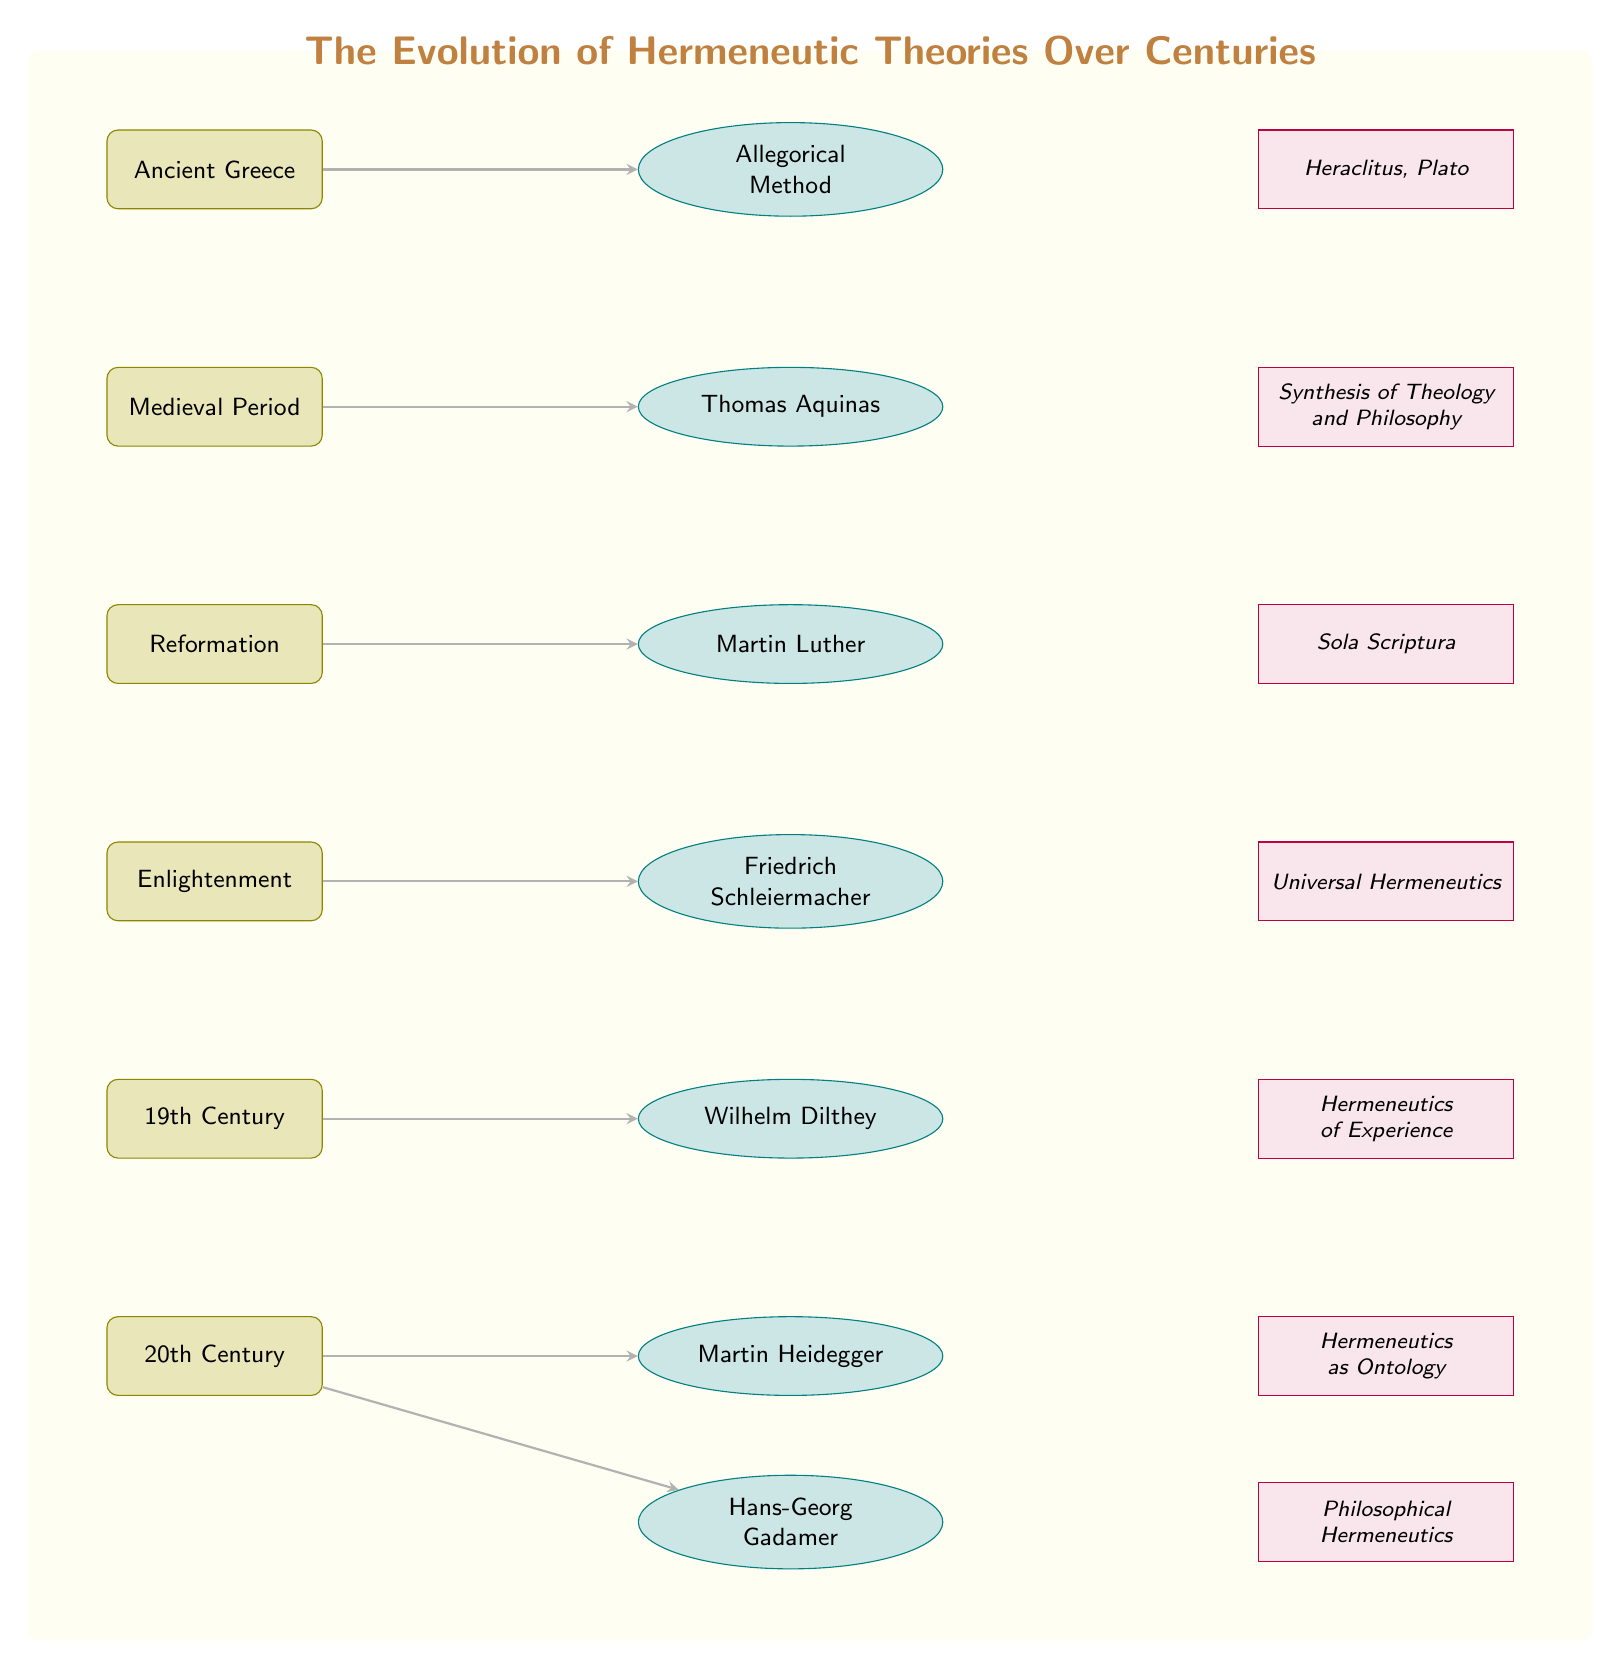What is the philosopher associated with the Medieval Period? The diagram shows Thomas Aquinas as the philosopher listed under the Medieval Period, indicated by the node positioned directly underneath the Medieval Period time period.
Answer: Thomas Aquinas Which method is linked to Ancient Greece? In the diagram, the Allegorical Method is displayed adjacent to the Ancient Greece node, indicating its association with that time period.
Answer: Allegorical Method How many philosophers are listed in the 20th Century? By counting the nodes connected to the 20th Century time period, there are two philosophers: Martin Heidegger and Hans-Georg Gadamer, who are both shown in ellipses right of the 20th Century node.
Answer: 2 What is the contribution of Friedrich Schleiermacher? The diagram labels Universal Hermeneutics next to Friedrich Schleiermacher, clarifying the significant contribution associated with this philosopher during the Enlightenment period.
Answer: Universal Hermeneutics What relationship exists between the Reformation and Sola Scriptura? The diagram provides a direct arrow from the Reformation to Martin Luther, and the contribution associated with Luther is Sola Scriptura, illustrating a clear relationship between these two elements.
Answer: Direct relationship Which century does the philosopher Wilhelm Dilthey belong to? The diagram delineates that Wilhelm Dilthey is a philosopher linked to the 19th Century, positioned under the 19th Century time period node.
Answer: 19th Century Who contributed to Hermeneutics as Ontology? According to the diagram, Martin Heidegger is noted as the philosopher who contributed the concept of Hermeneutics as Ontology in the 20th Century, directly indicated by the contribution next to his name.
Answer: Martin Heidegger What is the transitional connection between the Enlightenment and the 19th Century in this diagram? The diagram shows arrows flowing downward from the Enlightenment to the 19th Century period. This indicates a chronological transition where ideas from the Enlightenment period evolved into those discussed in the 19th Century.
Answer: Chronological transition 